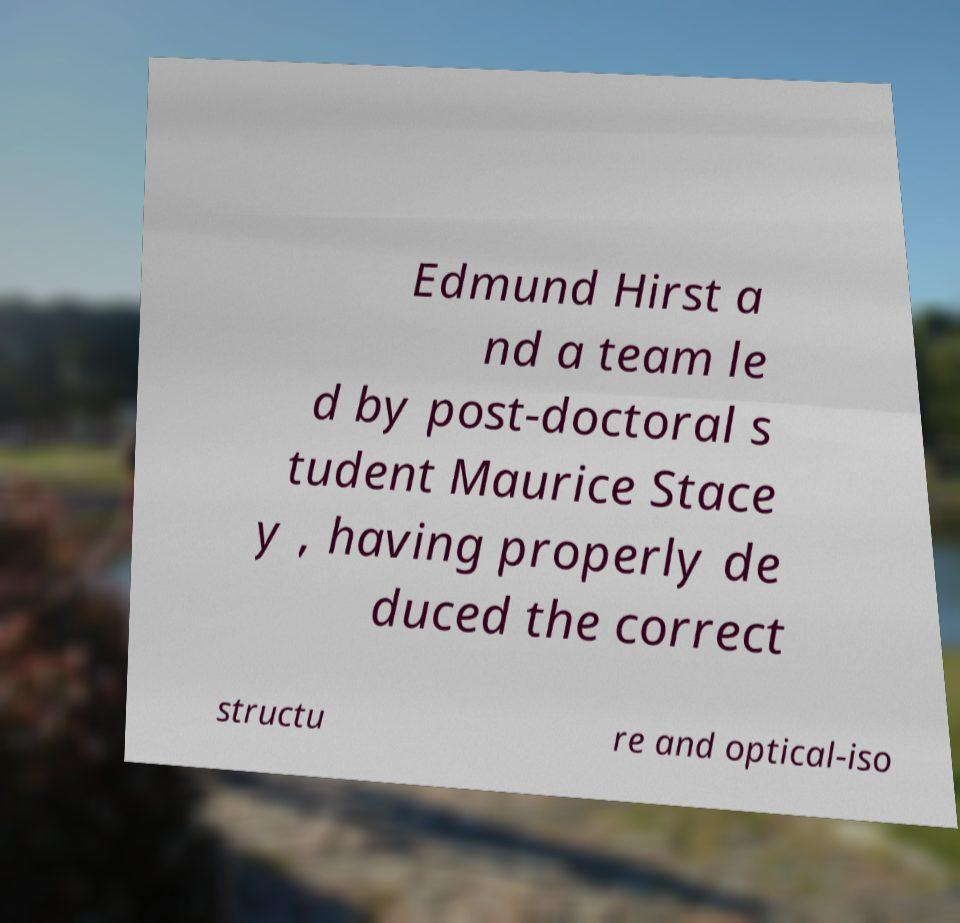Can you read and provide the text displayed in the image?This photo seems to have some interesting text. Can you extract and type it out for me? Edmund Hirst a nd a team le d by post-doctoral s tudent Maurice Stace y , having properly de duced the correct structu re and optical-iso 